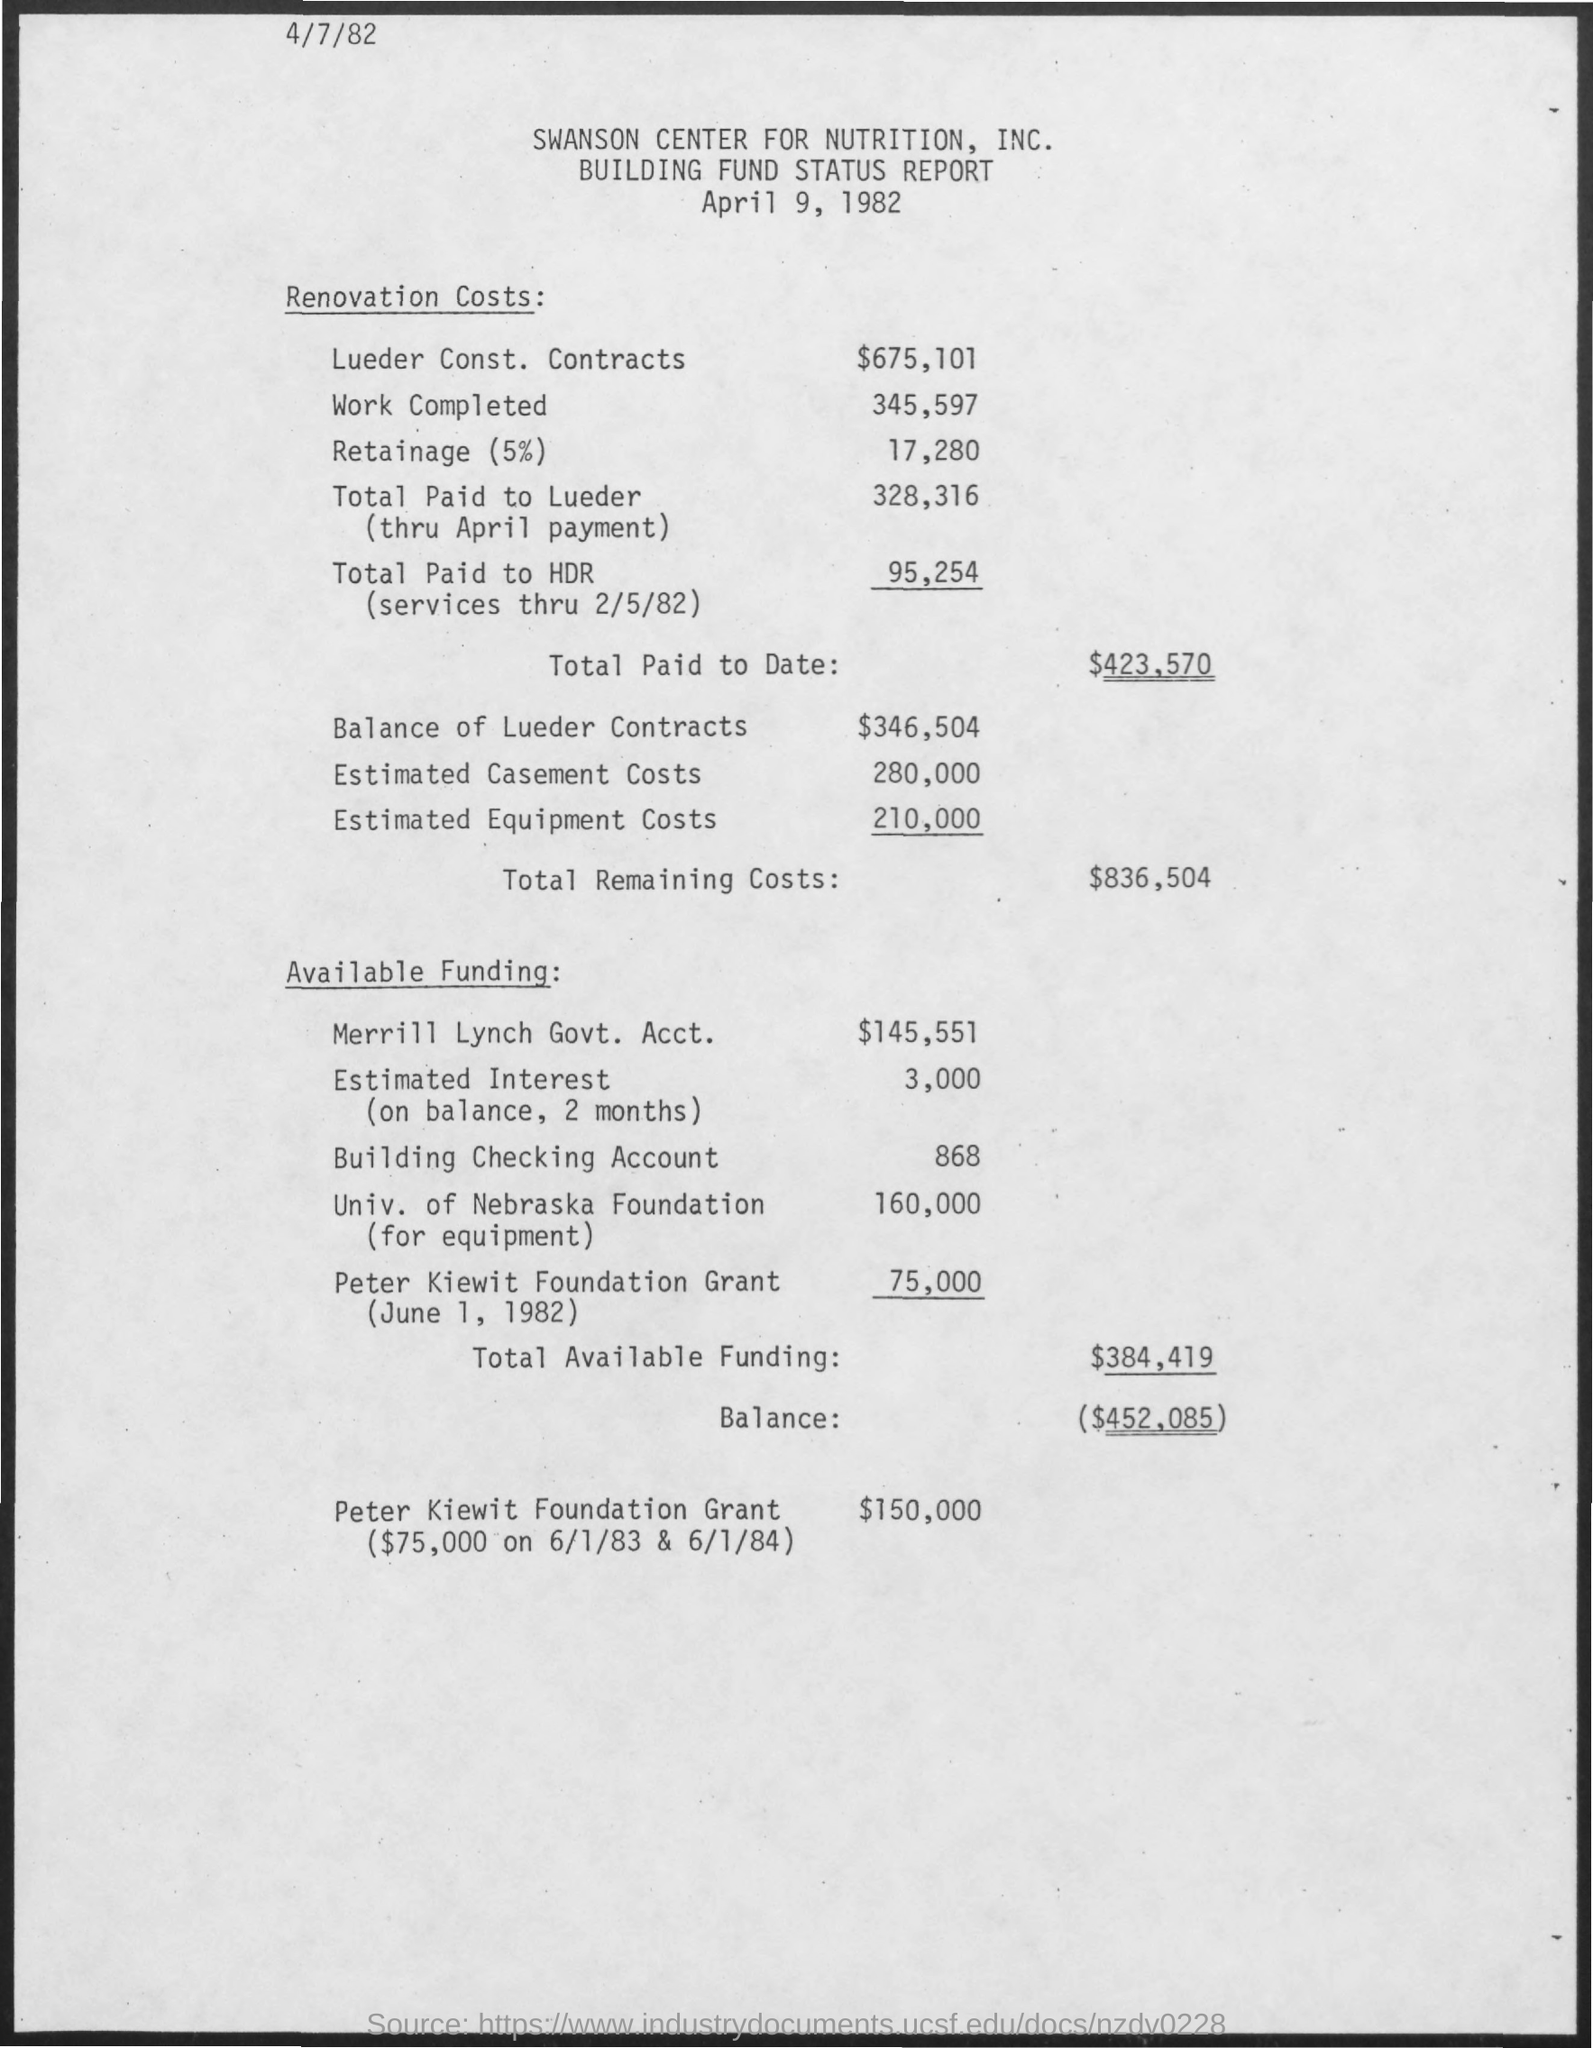What is the estimated equipment costs?
Provide a succinct answer. 210,000. What is the estimated casement costs?
Provide a succinct answer. 280,000. 